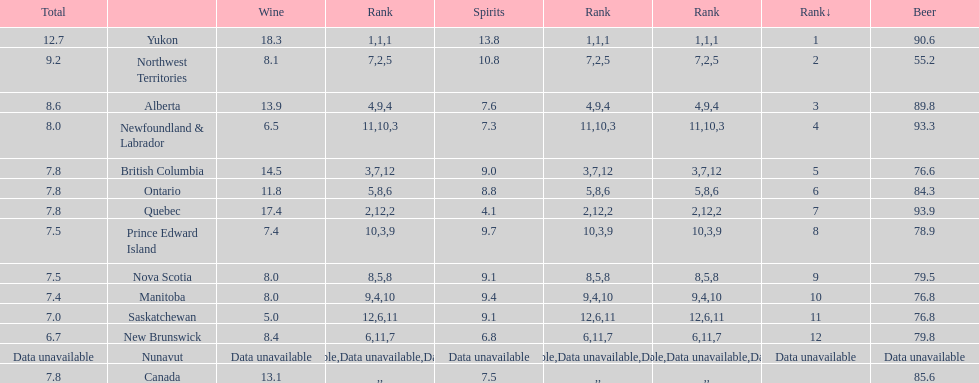Which province consumes the least amount of spirits? Quebec. 